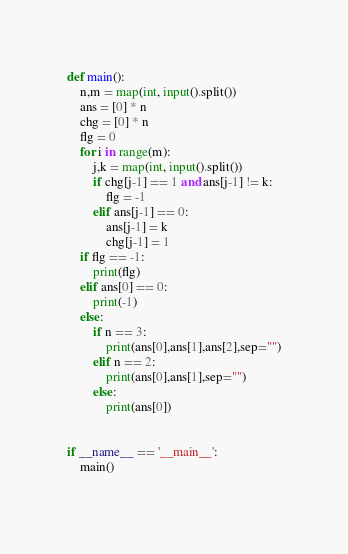Convert code to text. <code><loc_0><loc_0><loc_500><loc_500><_Python_>def main():
    n,m = map(int, input().split())
    ans = [0] * n
    chg = [0] * n
    flg = 0
    for i in range(m):
        j,k = map(int, input().split())
        if chg[j-1] == 1 and ans[j-1] != k:
            flg = -1
        elif ans[j-1] == 0:
            ans[j-1] = k
            chg[j-1] = 1
    if flg == -1:
        print(flg)
    elif ans[0] == 0:
        print(-1)
    else:
        if n == 3:
            print(ans[0],ans[1],ans[2],sep="")
        elif n == 2:
            print(ans[0],ans[1],sep="")
        else:
            print(ans[0])


if __name__ == '__main__':
    main()
   </code> 